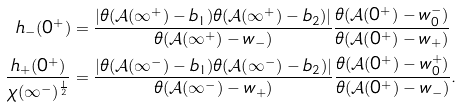<formula> <loc_0><loc_0><loc_500><loc_500>h _ { - } ( 0 ^ { + } ) & = \frac { \left | \theta ( \mathcal { A } ( \infty ^ { + } ) - b _ { 1 } ) \theta ( \mathcal { A } ( \infty ^ { + } ) - b _ { 2 } ) \right | } { \theta ( \mathcal { A } ( \infty ^ { + } ) - w _ { - } ) } \frac { \theta ( \mathcal { A } ( 0 ^ { + } ) - w _ { 0 } ^ { - } ) } { \theta ( \mathcal { A } ( 0 ^ { + } ) - w _ { + } ) } \\ \frac { h _ { + } ( 0 ^ { + } ) } { \chi ( \infty ^ { - } ) ^ { \frac { 1 } { 2 } } } & = \frac { \left | \theta ( \mathcal { A } ( \infty ^ { - } ) - b _ { 1 } ) \theta ( \mathcal { A } ( \infty ^ { - } ) - b _ { 2 } ) \right | } { \theta ( \mathcal { A } ( \infty ^ { - } ) - w _ { + } ) } \frac { \theta ( \mathcal { A } ( 0 ^ { + } ) - w _ { 0 } ^ { + } ) } { \theta ( \mathcal { A } ( 0 ^ { + } ) - w _ { - } ) } . \\</formula> 